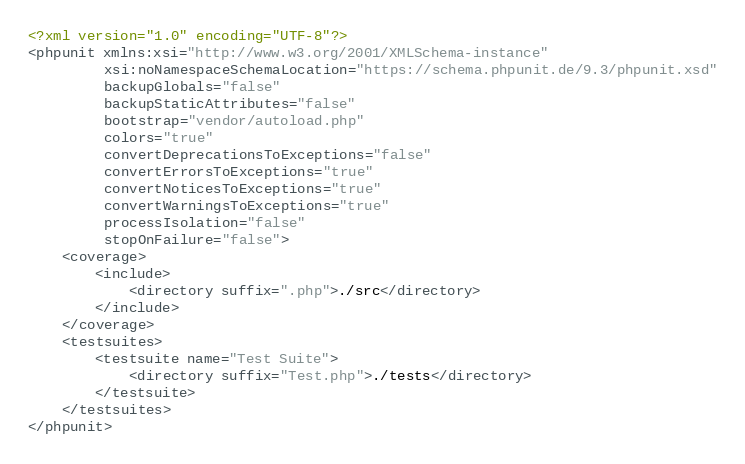Convert code to text. <code><loc_0><loc_0><loc_500><loc_500><_XML_><?xml version="1.0" encoding="UTF-8"?>
<phpunit xmlns:xsi="http://www.w3.org/2001/XMLSchema-instance"
         xsi:noNamespaceSchemaLocation="https://schema.phpunit.de/9.3/phpunit.xsd"
         backupGlobals="false"
         backupStaticAttributes="false"
         bootstrap="vendor/autoload.php"
         colors="true"
         convertDeprecationsToExceptions="false"
         convertErrorsToExceptions="true"
         convertNoticesToExceptions="true"
         convertWarningsToExceptions="true"
         processIsolation="false"
         stopOnFailure="false">
    <coverage>
        <include>
            <directory suffix=".php">./src</directory>
        </include>
    </coverage>
    <testsuites>
        <testsuite name="Test Suite">
            <directory suffix="Test.php">./tests</directory>
        </testsuite>
    </testsuites>
</phpunit>
</code> 